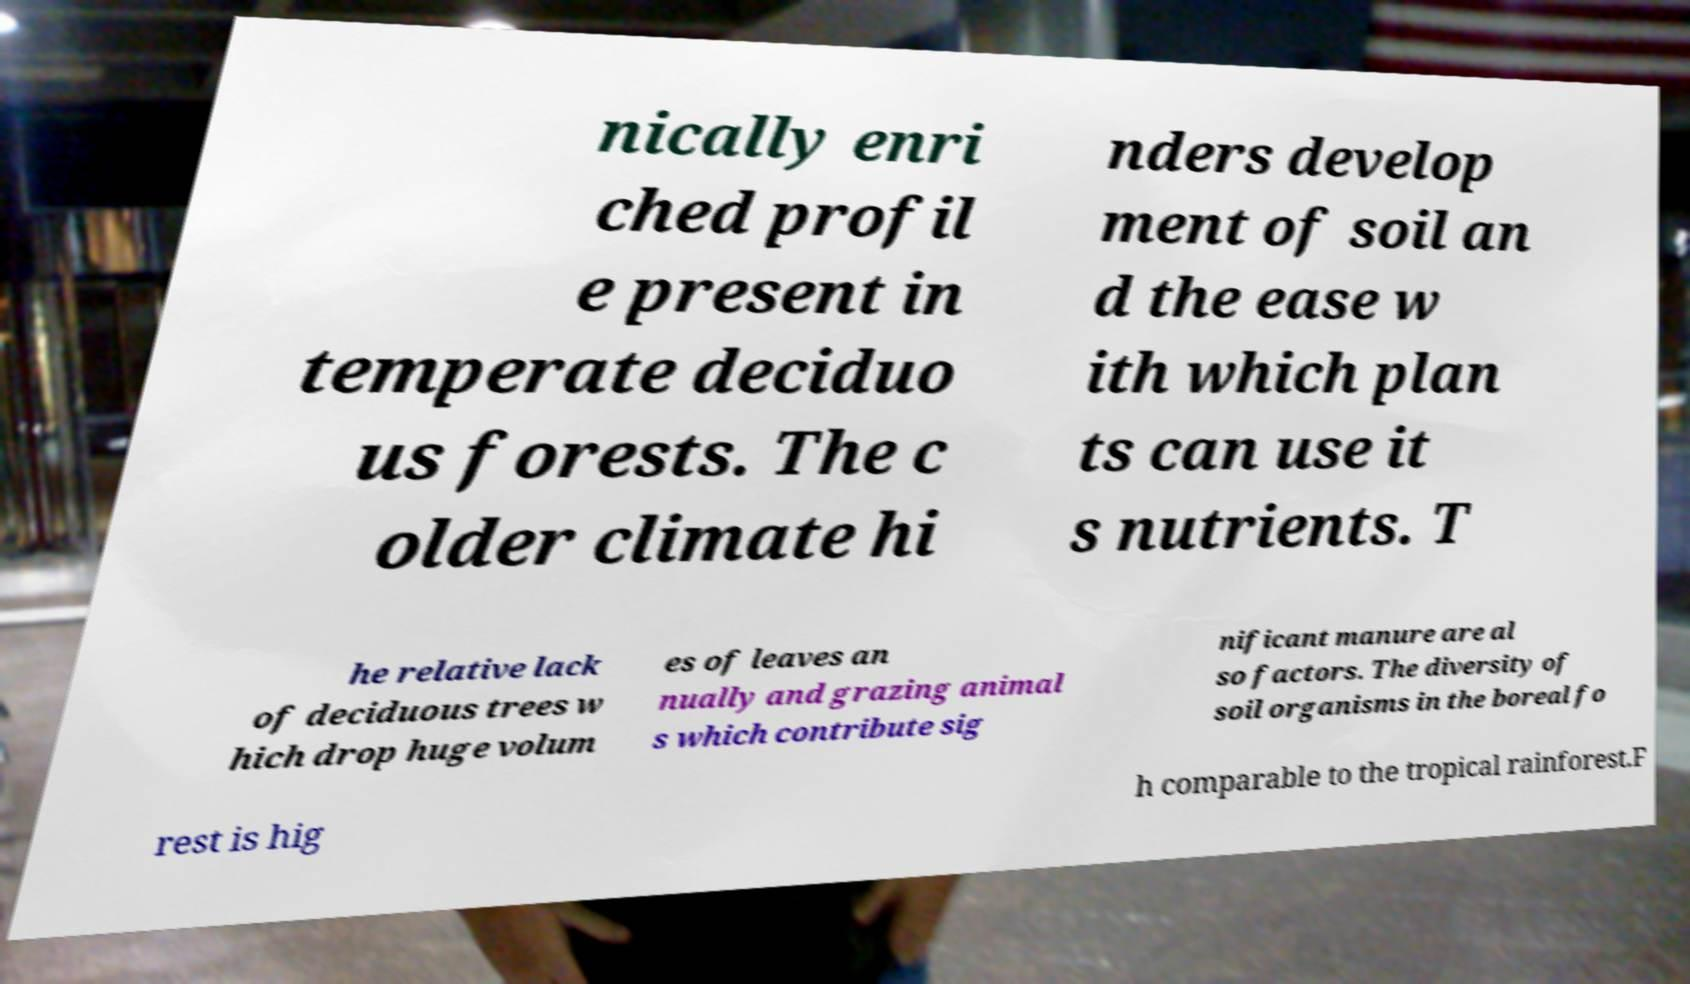Please identify and transcribe the text found in this image. nically enri ched profil e present in temperate deciduo us forests. The c older climate hi nders develop ment of soil an d the ease w ith which plan ts can use it s nutrients. T he relative lack of deciduous trees w hich drop huge volum es of leaves an nually and grazing animal s which contribute sig nificant manure are al so factors. The diversity of soil organisms in the boreal fo rest is hig h comparable to the tropical rainforest.F 